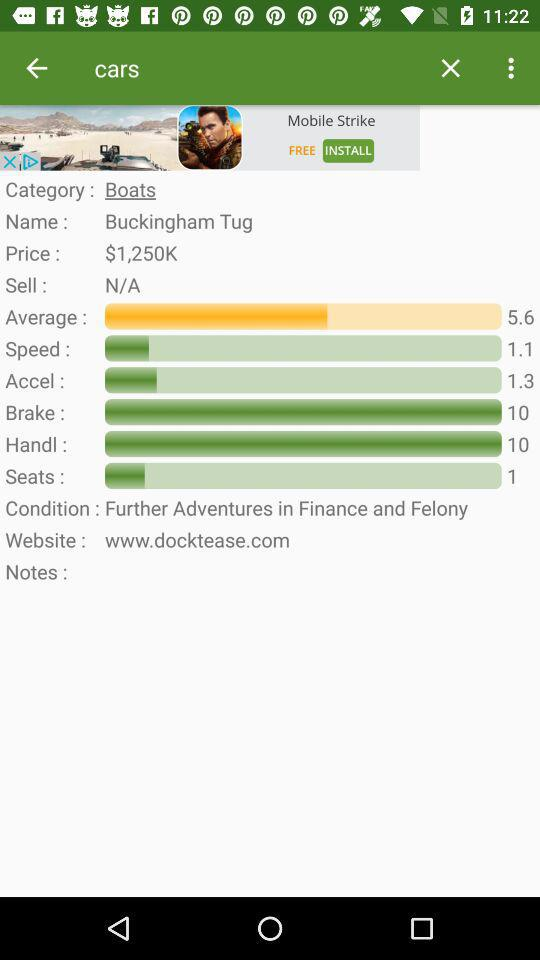What is the category? The category is "Boats". 